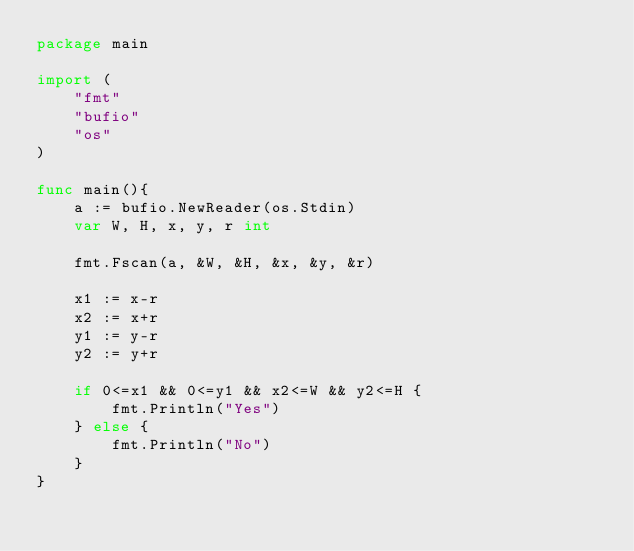Convert code to text. <code><loc_0><loc_0><loc_500><loc_500><_Go_>package main

import (
    "fmt"
    "bufio"
    "os"
)

func main(){
    a := bufio.NewReader(os.Stdin)
    var W, H, x, y, r int
    
    fmt.Fscan(a, &W, &H, &x, &y, &r)

    x1 := x-r
    x2 := x+r
    y1 := y-r
    y2 := y+r
    
    if 0<=x1 && 0<=y1 && x2<=W && y2<=H {
        fmt.Println("Yes")
    } else {
        fmt.Println("No")
    }
}
    
</code> 